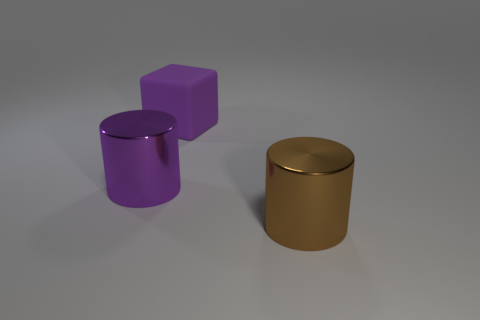How many other objects are the same color as the matte object?
Offer a very short reply. 1. Are there fewer big cubes than big metal things?
Your response must be concise. Yes. What is the shape of the large purple thing on the right side of the big purple thing that is on the left side of the rubber cube?
Provide a short and direct response. Cube. Are there any metal cylinders behind the brown thing?
Ensure brevity in your answer.  Yes. There is a rubber thing that is the same size as the purple metal cylinder; what is its color?
Ensure brevity in your answer.  Purple. What number of other objects have the same material as the large brown object?
Your answer should be very brief. 1. Is there a yellow shiny cube of the same size as the matte block?
Make the answer very short. No. There is a shiny thing that is left of the big brown cylinder; is its color the same as the rubber object?
Your answer should be very brief. Yes. What number of things are big green spheres or cylinders?
Keep it short and to the point. 2. There is a cylinder that is left of the brown cylinder; is its size the same as the purple rubber block?
Keep it short and to the point. Yes. 